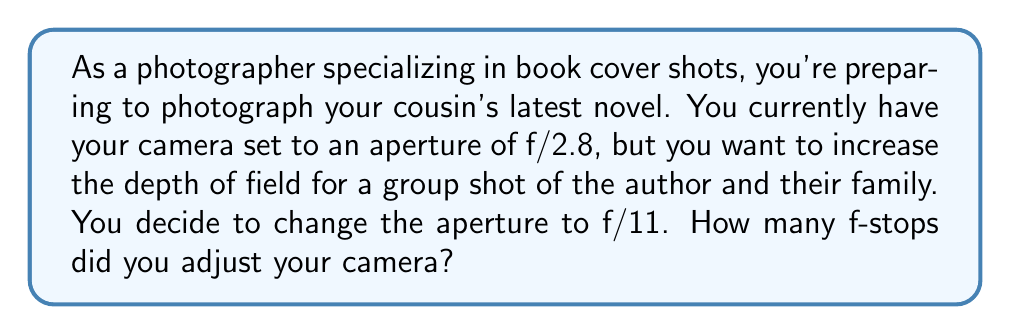Teach me how to tackle this problem. To solve this problem, we need to use the properties of logarithms, specifically the fact that f-stops are based on powers of $\sqrt{2}$.

1) First, let's recall the formula for calculating the number of f-stops between two aperture values:

   $$ \text{Number of f-stops} = \log_2\left(\frac{f_2^2}{f_1^2}\right) $$

   Where $f_1$ is the initial aperture value and $f_2$ is the final aperture value.

2) In this case, $f_1 = 2.8$ and $f_2 = 11$. Let's substitute these values:

   $$ \text{Number of f-stops} = \log_2\left(\frac{11^2}{2.8^2}\right) $$

3) Simplify inside the parentheses:

   $$ \text{Number of f-stops} = \log_2\left(\frac{121}{7.84}\right) $$

4) Divide:

   $$ \text{Number of f-stops} = \log_2(15.43) $$

5) To solve this, we can use the change of base formula:

   $$ \log_2(15.43) = \frac{\log(15.43)}{\log(2)} $$

6) Using a calculator:

   $$ \frac{\log(15.43)}{\log(2)} \approx 3.95 $$

7) Since f-stops are typically whole numbers, we round to the nearest integer:

   $$ 3.95 \approx 4 $$

Therefore, you adjusted your camera by 4 f-stops.
Answer: 4 f-stops 